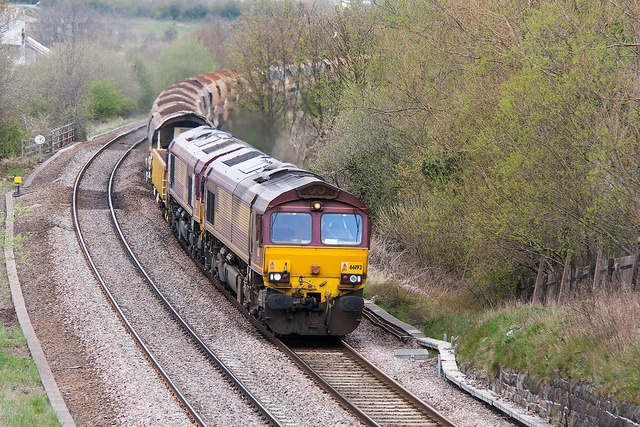Describe the objects in this image and their specific colors. I can see train in darkgray, black, gray, and lightgray tones and people in darkgray, lightblue, and lavender tones in this image. 